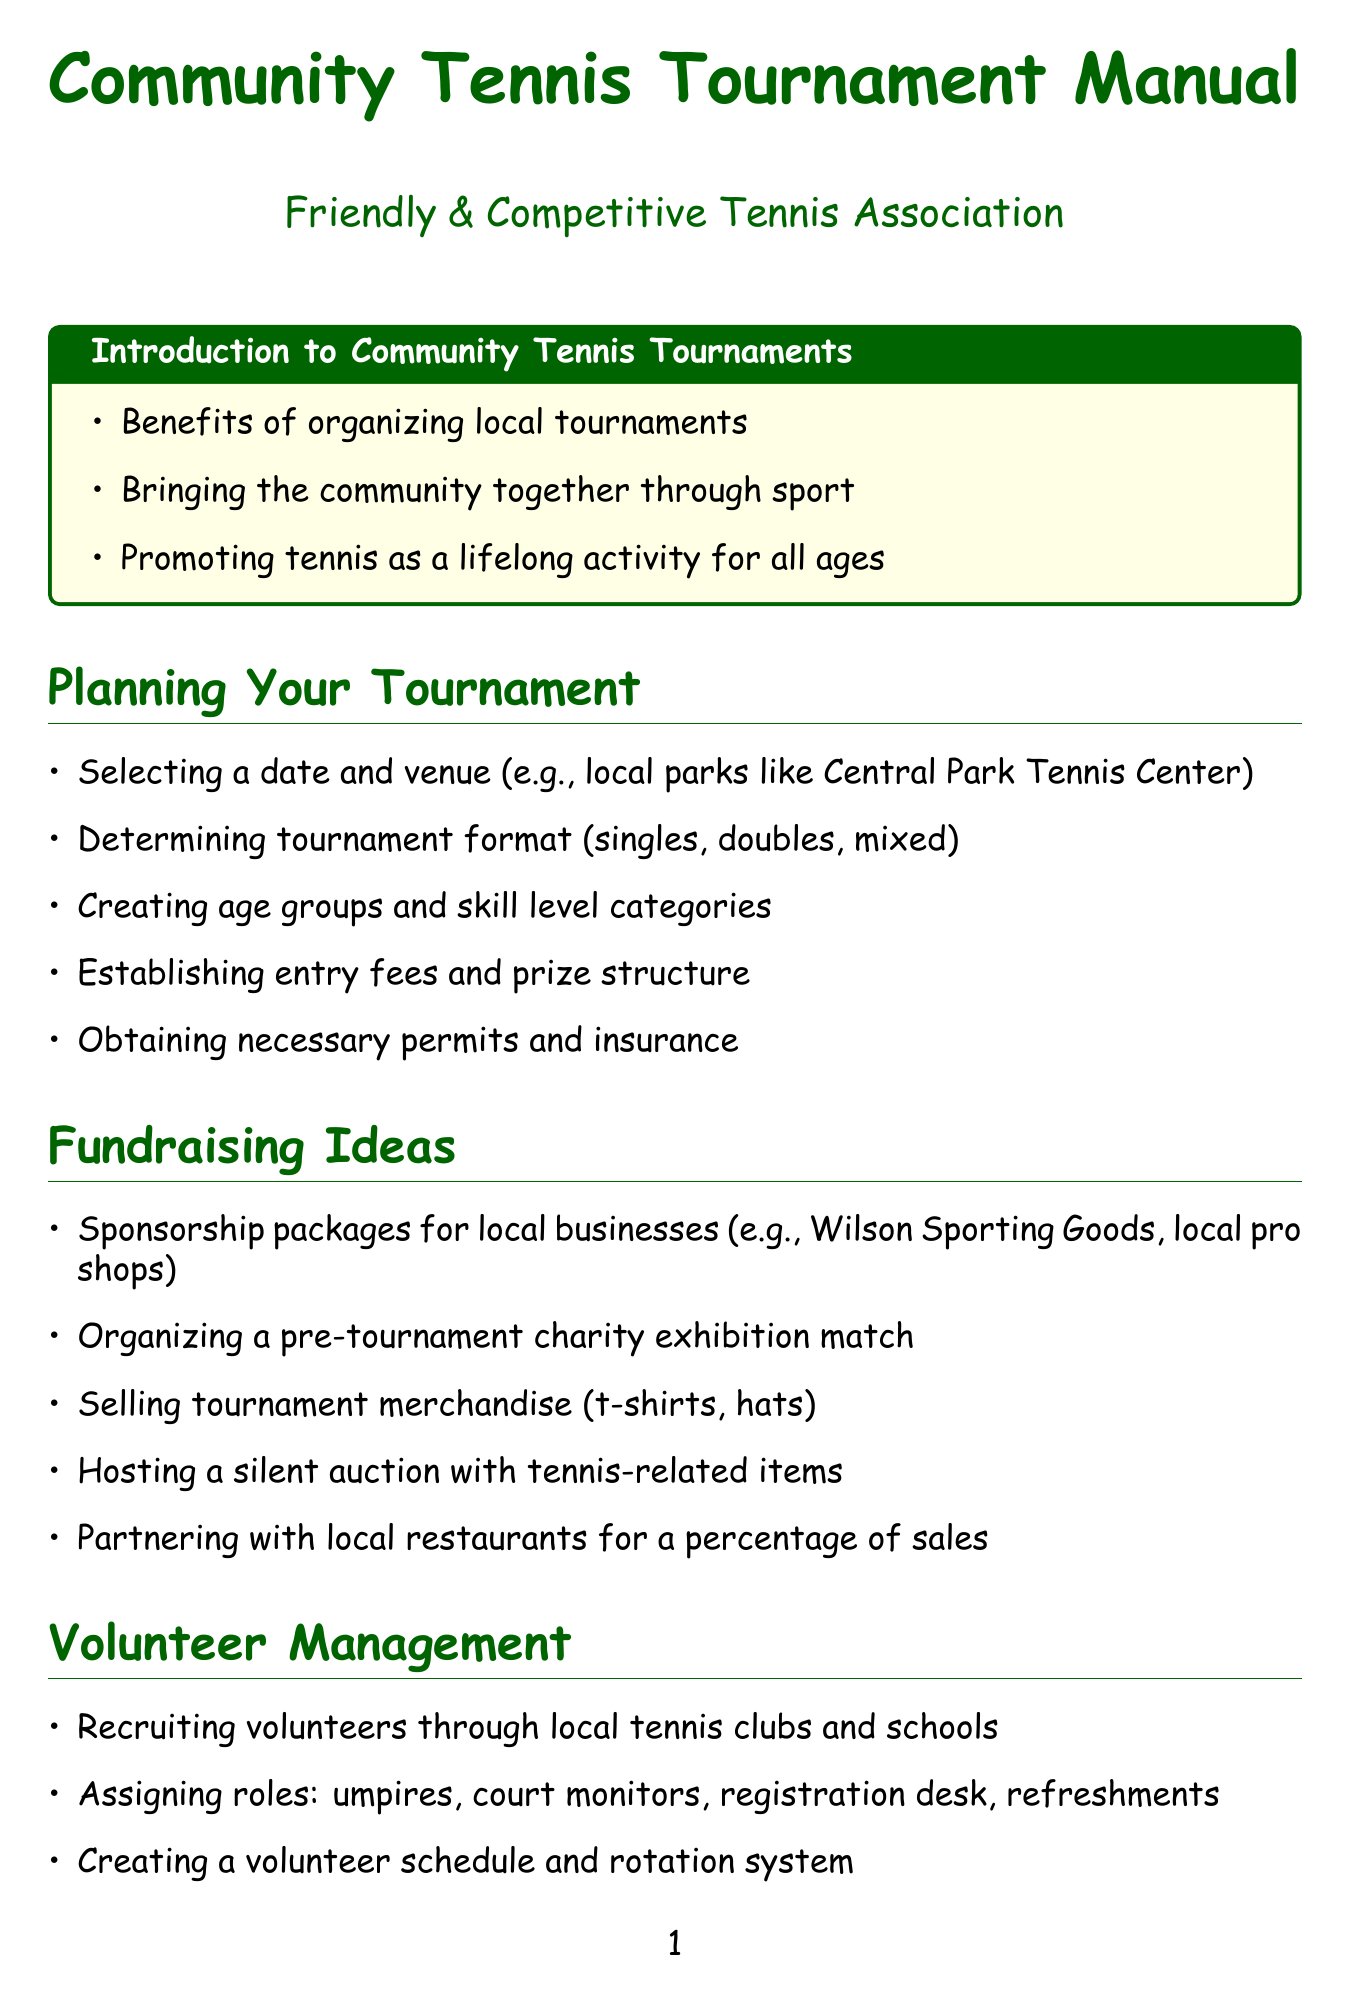What are the benefits of organizing local tournaments? The document lists the benefits which include bringing the community together and promoting tennis as a lifelong activity.
Answer: Benefits of organizing local tournaments, Bringing the community together through sport, Promoting tennis as a lifelong activity for all ages What is a unique fundraising idea mentioned in the manual? The manual provides several fundraising ideas, including sponsorship packages and organizing a charity match.
Answer: Organizing a pre-tournament charity exhibition match What should be included in the tournament execution process? The document outlines several tasks for tournament execution, including managing match schedules and providing refreshments.
Answer: Managing match schedules and court assignments Which section discusses volunteer management? The document has a dedicated section focusing on how to manage volunteers during the tournament.
Answer: Volunteer Management How can you encourage outdoor activities during the tournament? The manual describes various ways to promote outdoor activities, including organizing mini-tennis and showcasing other sports.
Answer: Incorporating family-friendly activities (e.g., mini-tennis for kids) What is a proposed activity for post-tournament? The document highlights several activities to be conducted after the tournament, such as collecting feedback and evaluating success.
Answer: Collecting feedback from participants and spectators What type of atmosphere does the manual recommend for the tournament? The manual specifically suggests creating a competitive yet friendly atmosphere with social events and awards.
Answer: Competitive yet friendly atmosphere Who can help recruit volunteers? The document suggests recruiting volunteers through local tennis clubs and schools.
Answer: Local tennis clubs and schools 